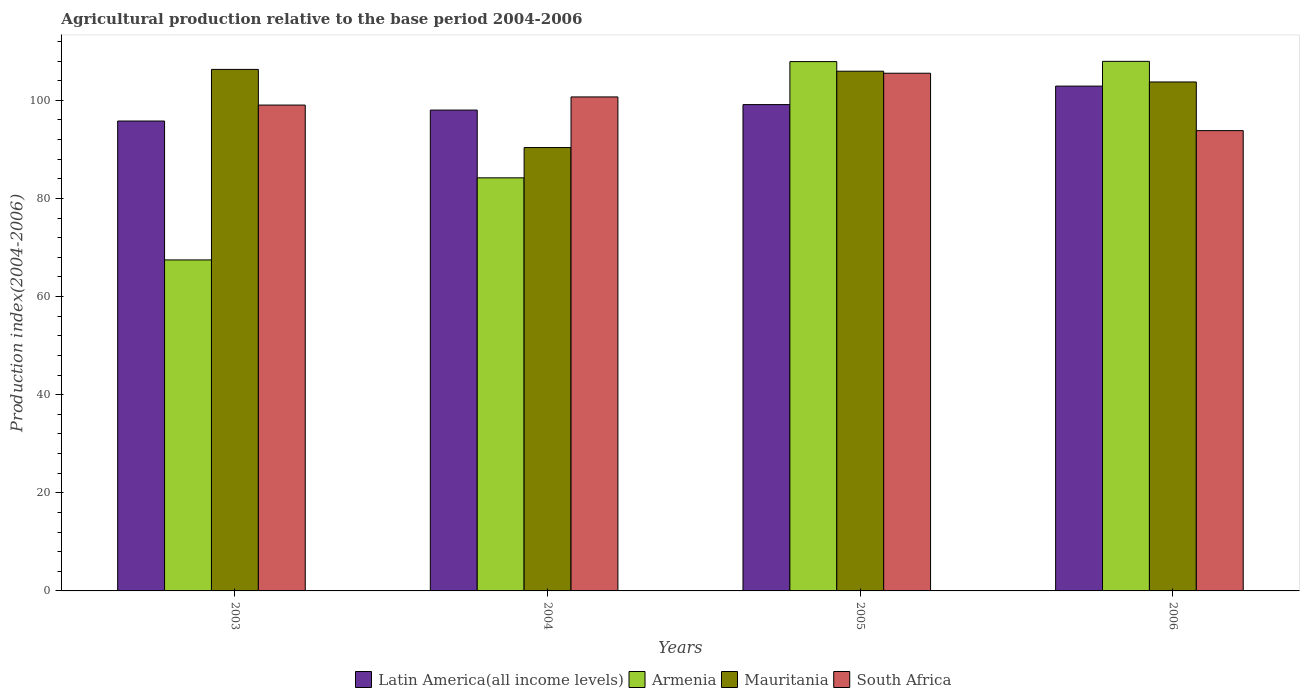How many different coloured bars are there?
Offer a terse response. 4. How many bars are there on the 4th tick from the left?
Offer a terse response. 4. In how many cases, is the number of bars for a given year not equal to the number of legend labels?
Offer a terse response. 0. What is the agricultural production index in Armenia in 2004?
Give a very brief answer. 84.19. Across all years, what is the maximum agricultural production index in South Africa?
Ensure brevity in your answer.  105.51. Across all years, what is the minimum agricultural production index in Latin America(all income levels)?
Your response must be concise. 95.77. What is the total agricultural production index in South Africa in the graph?
Your answer should be compact. 399.02. What is the difference between the agricultural production index in Mauritania in 2004 and that in 2006?
Your answer should be very brief. -13.37. What is the difference between the agricultural production index in South Africa in 2003 and the agricultural production index in Mauritania in 2004?
Your answer should be very brief. 8.66. What is the average agricultural production index in Armenia per year?
Give a very brief answer. 91.86. In the year 2003, what is the difference between the agricultural production index in Armenia and agricultural production index in South Africa?
Offer a terse response. -31.56. In how many years, is the agricultural production index in Latin America(all income levels) greater than 72?
Keep it short and to the point. 4. What is the ratio of the agricultural production index in Latin America(all income levels) in 2005 to that in 2006?
Keep it short and to the point. 0.96. Is the agricultural production index in Armenia in 2005 less than that in 2006?
Provide a short and direct response. Yes. Is the difference between the agricultural production index in Armenia in 2003 and 2006 greater than the difference between the agricultural production index in South Africa in 2003 and 2006?
Offer a very short reply. No. What is the difference between the highest and the second highest agricultural production index in South Africa?
Ensure brevity in your answer.  4.83. What is the difference between the highest and the lowest agricultural production index in South Africa?
Provide a succinct answer. 11.7. In how many years, is the agricultural production index in Armenia greater than the average agricultural production index in Armenia taken over all years?
Your answer should be compact. 2. Is the sum of the agricultural production index in Armenia in 2003 and 2006 greater than the maximum agricultural production index in South Africa across all years?
Offer a terse response. Yes. Is it the case that in every year, the sum of the agricultural production index in Mauritania and agricultural production index in South Africa is greater than the sum of agricultural production index in Latin America(all income levels) and agricultural production index in Armenia?
Make the answer very short. No. What does the 4th bar from the left in 2005 represents?
Provide a short and direct response. South Africa. What does the 1st bar from the right in 2004 represents?
Your response must be concise. South Africa. Is it the case that in every year, the sum of the agricultural production index in Mauritania and agricultural production index in Latin America(all income levels) is greater than the agricultural production index in Armenia?
Your answer should be compact. Yes. How many bars are there?
Keep it short and to the point. 16. Are all the bars in the graph horizontal?
Provide a succinct answer. No. Are the values on the major ticks of Y-axis written in scientific E-notation?
Your answer should be compact. No. Does the graph contain any zero values?
Your answer should be very brief. No. Does the graph contain grids?
Offer a terse response. No. Where does the legend appear in the graph?
Your response must be concise. Bottom center. How are the legend labels stacked?
Your answer should be compact. Horizontal. What is the title of the graph?
Offer a terse response. Agricultural production relative to the base period 2004-2006. Does "Myanmar" appear as one of the legend labels in the graph?
Provide a short and direct response. No. What is the label or title of the Y-axis?
Make the answer very short. Production index(2004-2006). What is the Production index(2004-2006) of Latin America(all income levels) in 2003?
Provide a short and direct response. 95.77. What is the Production index(2004-2006) in Armenia in 2003?
Ensure brevity in your answer.  67.46. What is the Production index(2004-2006) of Mauritania in 2003?
Offer a terse response. 106.29. What is the Production index(2004-2006) of South Africa in 2003?
Give a very brief answer. 99.02. What is the Production index(2004-2006) in Latin America(all income levels) in 2004?
Ensure brevity in your answer.  98. What is the Production index(2004-2006) in Armenia in 2004?
Offer a very short reply. 84.19. What is the Production index(2004-2006) of Mauritania in 2004?
Make the answer very short. 90.36. What is the Production index(2004-2006) in South Africa in 2004?
Your answer should be compact. 100.68. What is the Production index(2004-2006) of Latin America(all income levels) in 2005?
Give a very brief answer. 99.12. What is the Production index(2004-2006) of Armenia in 2005?
Provide a short and direct response. 107.88. What is the Production index(2004-2006) of Mauritania in 2005?
Provide a short and direct response. 105.92. What is the Production index(2004-2006) in South Africa in 2005?
Provide a short and direct response. 105.51. What is the Production index(2004-2006) in Latin America(all income levels) in 2006?
Provide a succinct answer. 102.88. What is the Production index(2004-2006) of Armenia in 2006?
Make the answer very short. 107.93. What is the Production index(2004-2006) in Mauritania in 2006?
Your answer should be compact. 103.73. What is the Production index(2004-2006) of South Africa in 2006?
Make the answer very short. 93.81. Across all years, what is the maximum Production index(2004-2006) in Latin America(all income levels)?
Your answer should be very brief. 102.88. Across all years, what is the maximum Production index(2004-2006) of Armenia?
Provide a succinct answer. 107.93. Across all years, what is the maximum Production index(2004-2006) of Mauritania?
Your answer should be very brief. 106.29. Across all years, what is the maximum Production index(2004-2006) in South Africa?
Provide a short and direct response. 105.51. Across all years, what is the minimum Production index(2004-2006) of Latin America(all income levels)?
Your answer should be very brief. 95.77. Across all years, what is the minimum Production index(2004-2006) of Armenia?
Provide a short and direct response. 67.46. Across all years, what is the minimum Production index(2004-2006) of Mauritania?
Give a very brief answer. 90.36. Across all years, what is the minimum Production index(2004-2006) of South Africa?
Your answer should be very brief. 93.81. What is the total Production index(2004-2006) of Latin America(all income levels) in the graph?
Provide a short and direct response. 395.77. What is the total Production index(2004-2006) in Armenia in the graph?
Provide a short and direct response. 367.46. What is the total Production index(2004-2006) in Mauritania in the graph?
Make the answer very short. 406.3. What is the total Production index(2004-2006) of South Africa in the graph?
Ensure brevity in your answer.  399.02. What is the difference between the Production index(2004-2006) in Latin America(all income levels) in 2003 and that in 2004?
Offer a very short reply. -2.23. What is the difference between the Production index(2004-2006) in Armenia in 2003 and that in 2004?
Keep it short and to the point. -16.73. What is the difference between the Production index(2004-2006) in Mauritania in 2003 and that in 2004?
Offer a very short reply. 15.93. What is the difference between the Production index(2004-2006) of South Africa in 2003 and that in 2004?
Provide a succinct answer. -1.66. What is the difference between the Production index(2004-2006) in Latin America(all income levels) in 2003 and that in 2005?
Your answer should be compact. -3.35. What is the difference between the Production index(2004-2006) of Armenia in 2003 and that in 2005?
Make the answer very short. -40.42. What is the difference between the Production index(2004-2006) of Mauritania in 2003 and that in 2005?
Offer a terse response. 0.37. What is the difference between the Production index(2004-2006) in South Africa in 2003 and that in 2005?
Your response must be concise. -6.49. What is the difference between the Production index(2004-2006) of Latin America(all income levels) in 2003 and that in 2006?
Your answer should be very brief. -7.11. What is the difference between the Production index(2004-2006) in Armenia in 2003 and that in 2006?
Provide a succinct answer. -40.47. What is the difference between the Production index(2004-2006) in Mauritania in 2003 and that in 2006?
Your answer should be compact. 2.56. What is the difference between the Production index(2004-2006) in South Africa in 2003 and that in 2006?
Your response must be concise. 5.21. What is the difference between the Production index(2004-2006) in Latin America(all income levels) in 2004 and that in 2005?
Keep it short and to the point. -1.12. What is the difference between the Production index(2004-2006) in Armenia in 2004 and that in 2005?
Your answer should be compact. -23.69. What is the difference between the Production index(2004-2006) of Mauritania in 2004 and that in 2005?
Your answer should be compact. -15.56. What is the difference between the Production index(2004-2006) in South Africa in 2004 and that in 2005?
Your answer should be very brief. -4.83. What is the difference between the Production index(2004-2006) in Latin America(all income levels) in 2004 and that in 2006?
Your answer should be compact. -4.88. What is the difference between the Production index(2004-2006) in Armenia in 2004 and that in 2006?
Provide a short and direct response. -23.74. What is the difference between the Production index(2004-2006) of Mauritania in 2004 and that in 2006?
Make the answer very short. -13.37. What is the difference between the Production index(2004-2006) of South Africa in 2004 and that in 2006?
Your response must be concise. 6.87. What is the difference between the Production index(2004-2006) of Latin America(all income levels) in 2005 and that in 2006?
Make the answer very short. -3.77. What is the difference between the Production index(2004-2006) of Armenia in 2005 and that in 2006?
Your answer should be very brief. -0.05. What is the difference between the Production index(2004-2006) in Mauritania in 2005 and that in 2006?
Your response must be concise. 2.19. What is the difference between the Production index(2004-2006) in South Africa in 2005 and that in 2006?
Make the answer very short. 11.7. What is the difference between the Production index(2004-2006) in Latin America(all income levels) in 2003 and the Production index(2004-2006) in Armenia in 2004?
Offer a very short reply. 11.58. What is the difference between the Production index(2004-2006) of Latin America(all income levels) in 2003 and the Production index(2004-2006) of Mauritania in 2004?
Provide a short and direct response. 5.41. What is the difference between the Production index(2004-2006) of Latin America(all income levels) in 2003 and the Production index(2004-2006) of South Africa in 2004?
Make the answer very short. -4.91. What is the difference between the Production index(2004-2006) in Armenia in 2003 and the Production index(2004-2006) in Mauritania in 2004?
Your response must be concise. -22.9. What is the difference between the Production index(2004-2006) of Armenia in 2003 and the Production index(2004-2006) of South Africa in 2004?
Ensure brevity in your answer.  -33.22. What is the difference between the Production index(2004-2006) in Mauritania in 2003 and the Production index(2004-2006) in South Africa in 2004?
Provide a short and direct response. 5.61. What is the difference between the Production index(2004-2006) in Latin America(all income levels) in 2003 and the Production index(2004-2006) in Armenia in 2005?
Offer a very short reply. -12.11. What is the difference between the Production index(2004-2006) of Latin America(all income levels) in 2003 and the Production index(2004-2006) of Mauritania in 2005?
Keep it short and to the point. -10.15. What is the difference between the Production index(2004-2006) of Latin America(all income levels) in 2003 and the Production index(2004-2006) of South Africa in 2005?
Your answer should be very brief. -9.74. What is the difference between the Production index(2004-2006) of Armenia in 2003 and the Production index(2004-2006) of Mauritania in 2005?
Offer a terse response. -38.46. What is the difference between the Production index(2004-2006) in Armenia in 2003 and the Production index(2004-2006) in South Africa in 2005?
Provide a succinct answer. -38.05. What is the difference between the Production index(2004-2006) of Mauritania in 2003 and the Production index(2004-2006) of South Africa in 2005?
Make the answer very short. 0.78. What is the difference between the Production index(2004-2006) in Latin America(all income levels) in 2003 and the Production index(2004-2006) in Armenia in 2006?
Offer a very short reply. -12.16. What is the difference between the Production index(2004-2006) in Latin America(all income levels) in 2003 and the Production index(2004-2006) in Mauritania in 2006?
Provide a short and direct response. -7.96. What is the difference between the Production index(2004-2006) of Latin America(all income levels) in 2003 and the Production index(2004-2006) of South Africa in 2006?
Give a very brief answer. 1.96. What is the difference between the Production index(2004-2006) of Armenia in 2003 and the Production index(2004-2006) of Mauritania in 2006?
Your answer should be compact. -36.27. What is the difference between the Production index(2004-2006) in Armenia in 2003 and the Production index(2004-2006) in South Africa in 2006?
Offer a very short reply. -26.35. What is the difference between the Production index(2004-2006) in Mauritania in 2003 and the Production index(2004-2006) in South Africa in 2006?
Offer a very short reply. 12.48. What is the difference between the Production index(2004-2006) in Latin America(all income levels) in 2004 and the Production index(2004-2006) in Armenia in 2005?
Your response must be concise. -9.88. What is the difference between the Production index(2004-2006) in Latin America(all income levels) in 2004 and the Production index(2004-2006) in Mauritania in 2005?
Make the answer very short. -7.92. What is the difference between the Production index(2004-2006) of Latin America(all income levels) in 2004 and the Production index(2004-2006) of South Africa in 2005?
Make the answer very short. -7.51. What is the difference between the Production index(2004-2006) in Armenia in 2004 and the Production index(2004-2006) in Mauritania in 2005?
Your answer should be very brief. -21.73. What is the difference between the Production index(2004-2006) of Armenia in 2004 and the Production index(2004-2006) of South Africa in 2005?
Make the answer very short. -21.32. What is the difference between the Production index(2004-2006) of Mauritania in 2004 and the Production index(2004-2006) of South Africa in 2005?
Your answer should be compact. -15.15. What is the difference between the Production index(2004-2006) of Latin America(all income levels) in 2004 and the Production index(2004-2006) of Armenia in 2006?
Your answer should be compact. -9.93. What is the difference between the Production index(2004-2006) of Latin America(all income levels) in 2004 and the Production index(2004-2006) of Mauritania in 2006?
Your response must be concise. -5.73. What is the difference between the Production index(2004-2006) of Latin America(all income levels) in 2004 and the Production index(2004-2006) of South Africa in 2006?
Make the answer very short. 4.19. What is the difference between the Production index(2004-2006) in Armenia in 2004 and the Production index(2004-2006) in Mauritania in 2006?
Your answer should be compact. -19.54. What is the difference between the Production index(2004-2006) in Armenia in 2004 and the Production index(2004-2006) in South Africa in 2006?
Your response must be concise. -9.62. What is the difference between the Production index(2004-2006) in Mauritania in 2004 and the Production index(2004-2006) in South Africa in 2006?
Provide a short and direct response. -3.45. What is the difference between the Production index(2004-2006) in Latin America(all income levels) in 2005 and the Production index(2004-2006) in Armenia in 2006?
Provide a short and direct response. -8.81. What is the difference between the Production index(2004-2006) of Latin America(all income levels) in 2005 and the Production index(2004-2006) of Mauritania in 2006?
Keep it short and to the point. -4.61. What is the difference between the Production index(2004-2006) of Latin America(all income levels) in 2005 and the Production index(2004-2006) of South Africa in 2006?
Make the answer very short. 5.31. What is the difference between the Production index(2004-2006) in Armenia in 2005 and the Production index(2004-2006) in Mauritania in 2006?
Make the answer very short. 4.15. What is the difference between the Production index(2004-2006) of Armenia in 2005 and the Production index(2004-2006) of South Africa in 2006?
Provide a succinct answer. 14.07. What is the difference between the Production index(2004-2006) in Mauritania in 2005 and the Production index(2004-2006) in South Africa in 2006?
Your response must be concise. 12.11. What is the average Production index(2004-2006) in Latin America(all income levels) per year?
Offer a very short reply. 98.94. What is the average Production index(2004-2006) in Armenia per year?
Give a very brief answer. 91.86. What is the average Production index(2004-2006) of Mauritania per year?
Provide a succinct answer. 101.58. What is the average Production index(2004-2006) in South Africa per year?
Offer a terse response. 99.75. In the year 2003, what is the difference between the Production index(2004-2006) of Latin America(all income levels) and Production index(2004-2006) of Armenia?
Offer a terse response. 28.31. In the year 2003, what is the difference between the Production index(2004-2006) of Latin America(all income levels) and Production index(2004-2006) of Mauritania?
Your response must be concise. -10.52. In the year 2003, what is the difference between the Production index(2004-2006) of Latin America(all income levels) and Production index(2004-2006) of South Africa?
Provide a short and direct response. -3.25. In the year 2003, what is the difference between the Production index(2004-2006) of Armenia and Production index(2004-2006) of Mauritania?
Your answer should be compact. -38.83. In the year 2003, what is the difference between the Production index(2004-2006) in Armenia and Production index(2004-2006) in South Africa?
Keep it short and to the point. -31.56. In the year 2003, what is the difference between the Production index(2004-2006) of Mauritania and Production index(2004-2006) of South Africa?
Keep it short and to the point. 7.27. In the year 2004, what is the difference between the Production index(2004-2006) of Latin America(all income levels) and Production index(2004-2006) of Armenia?
Your answer should be compact. 13.81. In the year 2004, what is the difference between the Production index(2004-2006) of Latin America(all income levels) and Production index(2004-2006) of Mauritania?
Provide a succinct answer. 7.64. In the year 2004, what is the difference between the Production index(2004-2006) in Latin America(all income levels) and Production index(2004-2006) in South Africa?
Offer a terse response. -2.68. In the year 2004, what is the difference between the Production index(2004-2006) in Armenia and Production index(2004-2006) in Mauritania?
Your answer should be compact. -6.17. In the year 2004, what is the difference between the Production index(2004-2006) in Armenia and Production index(2004-2006) in South Africa?
Your response must be concise. -16.49. In the year 2004, what is the difference between the Production index(2004-2006) of Mauritania and Production index(2004-2006) of South Africa?
Your answer should be very brief. -10.32. In the year 2005, what is the difference between the Production index(2004-2006) of Latin America(all income levels) and Production index(2004-2006) of Armenia?
Your response must be concise. -8.76. In the year 2005, what is the difference between the Production index(2004-2006) in Latin America(all income levels) and Production index(2004-2006) in Mauritania?
Provide a succinct answer. -6.8. In the year 2005, what is the difference between the Production index(2004-2006) in Latin America(all income levels) and Production index(2004-2006) in South Africa?
Make the answer very short. -6.39. In the year 2005, what is the difference between the Production index(2004-2006) in Armenia and Production index(2004-2006) in Mauritania?
Offer a very short reply. 1.96. In the year 2005, what is the difference between the Production index(2004-2006) of Armenia and Production index(2004-2006) of South Africa?
Your answer should be very brief. 2.37. In the year 2005, what is the difference between the Production index(2004-2006) in Mauritania and Production index(2004-2006) in South Africa?
Provide a succinct answer. 0.41. In the year 2006, what is the difference between the Production index(2004-2006) of Latin America(all income levels) and Production index(2004-2006) of Armenia?
Make the answer very short. -5.05. In the year 2006, what is the difference between the Production index(2004-2006) in Latin America(all income levels) and Production index(2004-2006) in Mauritania?
Keep it short and to the point. -0.85. In the year 2006, what is the difference between the Production index(2004-2006) of Latin America(all income levels) and Production index(2004-2006) of South Africa?
Provide a succinct answer. 9.07. In the year 2006, what is the difference between the Production index(2004-2006) in Armenia and Production index(2004-2006) in Mauritania?
Provide a short and direct response. 4.2. In the year 2006, what is the difference between the Production index(2004-2006) in Armenia and Production index(2004-2006) in South Africa?
Your answer should be very brief. 14.12. In the year 2006, what is the difference between the Production index(2004-2006) in Mauritania and Production index(2004-2006) in South Africa?
Ensure brevity in your answer.  9.92. What is the ratio of the Production index(2004-2006) of Latin America(all income levels) in 2003 to that in 2004?
Provide a succinct answer. 0.98. What is the ratio of the Production index(2004-2006) of Armenia in 2003 to that in 2004?
Provide a succinct answer. 0.8. What is the ratio of the Production index(2004-2006) in Mauritania in 2003 to that in 2004?
Your answer should be very brief. 1.18. What is the ratio of the Production index(2004-2006) of South Africa in 2003 to that in 2004?
Offer a very short reply. 0.98. What is the ratio of the Production index(2004-2006) of Latin America(all income levels) in 2003 to that in 2005?
Keep it short and to the point. 0.97. What is the ratio of the Production index(2004-2006) in Armenia in 2003 to that in 2005?
Provide a short and direct response. 0.63. What is the ratio of the Production index(2004-2006) of South Africa in 2003 to that in 2005?
Provide a succinct answer. 0.94. What is the ratio of the Production index(2004-2006) of Latin America(all income levels) in 2003 to that in 2006?
Keep it short and to the point. 0.93. What is the ratio of the Production index(2004-2006) in Mauritania in 2003 to that in 2006?
Offer a very short reply. 1.02. What is the ratio of the Production index(2004-2006) in South Africa in 2003 to that in 2006?
Give a very brief answer. 1.06. What is the ratio of the Production index(2004-2006) in Latin America(all income levels) in 2004 to that in 2005?
Provide a succinct answer. 0.99. What is the ratio of the Production index(2004-2006) of Armenia in 2004 to that in 2005?
Offer a terse response. 0.78. What is the ratio of the Production index(2004-2006) in Mauritania in 2004 to that in 2005?
Your response must be concise. 0.85. What is the ratio of the Production index(2004-2006) in South Africa in 2004 to that in 2005?
Ensure brevity in your answer.  0.95. What is the ratio of the Production index(2004-2006) of Latin America(all income levels) in 2004 to that in 2006?
Make the answer very short. 0.95. What is the ratio of the Production index(2004-2006) in Armenia in 2004 to that in 2006?
Ensure brevity in your answer.  0.78. What is the ratio of the Production index(2004-2006) of Mauritania in 2004 to that in 2006?
Offer a very short reply. 0.87. What is the ratio of the Production index(2004-2006) in South Africa in 2004 to that in 2006?
Your response must be concise. 1.07. What is the ratio of the Production index(2004-2006) in Latin America(all income levels) in 2005 to that in 2006?
Offer a very short reply. 0.96. What is the ratio of the Production index(2004-2006) in Mauritania in 2005 to that in 2006?
Your answer should be very brief. 1.02. What is the ratio of the Production index(2004-2006) of South Africa in 2005 to that in 2006?
Give a very brief answer. 1.12. What is the difference between the highest and the second highest Production index(2004-2006) of Latin America(all income levels)?
Your answer should be compact. 3.77. What is the difference between the highest and the second highest Production index(2004-2006) in Mauritania?
Keep it short and to the point. 0.37. What is the difference between the highest and the second highest Production index(2004-2006) in South Africa?
Offer a very short reply. 4.83. What is the difference between the highest and the lowest Production index(2004-2006) in Latin America(all income levels)?
Ensure brevity in your answer.  7.11. What is the difference between the highest and the lowest Production index(2004-2006) in Armenia?
Give a very brief answer. 40.47. What is the difference between the highest and the lowest Production index(2004-2006) of Mauritania?
Ensure brevity in your answer.  15.93. What is the difference between the highest and the lowest Production index(2004-2006) in South Africa?
Provide a short and direct response. 11.7. 